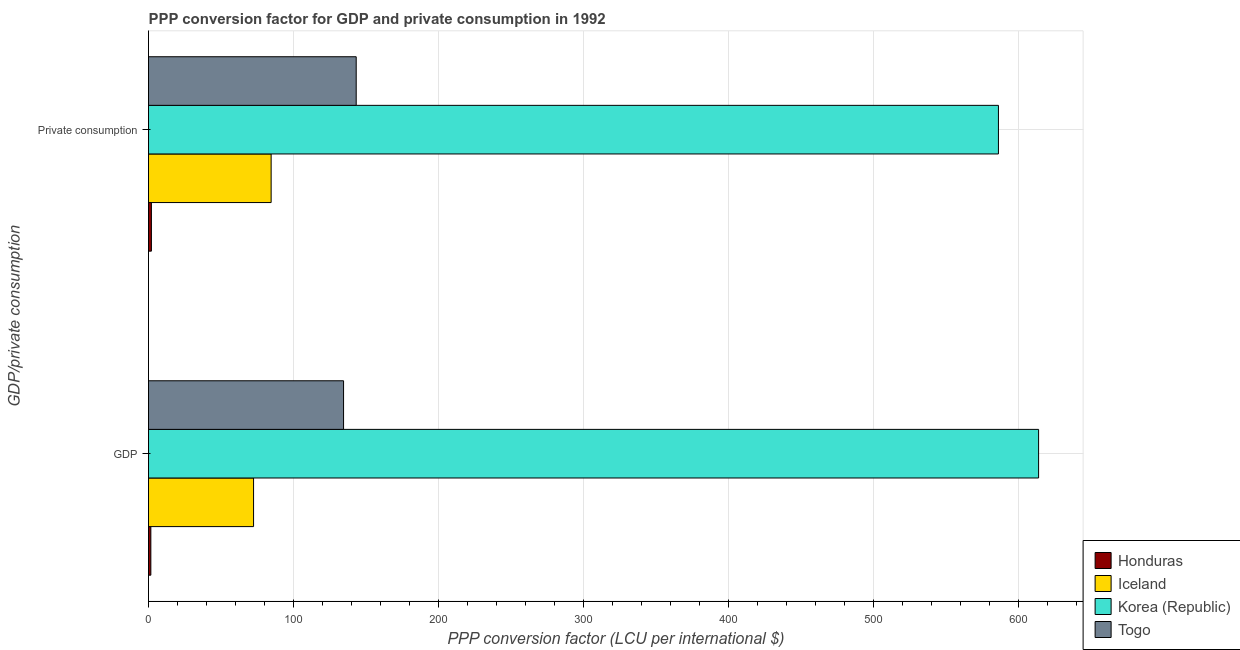How many groups of bars are there?
Your answer should be very brief. 2. Are the number of bars per tick equal to the number of legend labels?
Give a very brief answer. Yes. How many bars are there on the 2nd tick from the top?
Provide a succinct answer. 4. What is the label of the 1st group of bars from the top?
Provide a succinct answer.  Private consumption. What is the ppp conversion factor for gdp in Iceland?
Your answer should be very brief. 72.47. Across all countries, what is the maximum ppp conversion factor for gdp?
Offer a very short reply. 614.12. Across all countries, what is the minimum ppp conversion factor for private consumption?
Offer a very short reply. 1.99. In which country was the ppp conversion factor for gdp minimum?
Your answer should be compact. Honduras. What is the total ppp conversion factor for private consumption in the graph?
Make the answer very short. 816.31. What is the difference between the ppp conversion factor for private consumption in Togo and that in Korea (Republic)?
Offer a terse response. -443.11. What is the difference between the ppp conversion factor for gdp in Togo and the ppp conversion factor for private consumption in Honduras?
Give a very brief answer. 132.58. What is the average ppp conversion factor for private consumption per country?
Offer a very short reply. 204.08. What is the difference between the ppp conversion factor for gdp and ppp conversion factor for private consumption in Togo?
Offer a terse response. -8.73. What is the ratio of the ppp conversion factor for private consumption in Togo to that in Iceland?
Give a very brief answer. 1.69. In how many countries, is the ppp conversion factor for private consumption greater than the average ppp conversion factor for private consumption taken over all countries?
Keep it short and to the point. 1. Are all the bars in the graph horizontal?
Your answer should be compact. Yes. How many countries are there in the graph?
Provide a short and direct response. 4. Are the values on the major ticks of X-axis written in scientific E-notation?
Offer a very short reply. No. Does the graph contain grids?
Ensure brevity in your answer.  Yes. How many legend labels are there?
Offer a very short reply. 4. What is the title of the graph?
Keep it short and to the point. PPP conversion factor for GDP and private consumption in 1992. What is the label or title of the X-axis?
Make the answer very short. PPP conversion factor (LCU per international $). What is the label or title of the Y-axis?
Provide a short and direct response. GDP/private consumption. What is the PPP conversion factor (LCU per international $) in Honduras in GDP?
Give a very brief answer. 1.61. What is the PPP conversion factor (LCU per international $) in Iceland in GDP?
Your answer should be compact. 72.47. What is the PPP conversion factor (LCU per international $) in Korea (Republic) in GDP?
Keep it short and to the point. 614.12. What is the PPP conversion factor (LCU per international $) in Togo in GDP?
Give a very brief answer. 134.57. What is the PPP conversion factor (LCU per international $) in Honduras in  Private consumption?
Make the answer very short. 1.99. What is the PPP conversion factor (LCU per international $) of Iceland in  Private consumption?
Your response must be concise. 84.61. What is the PPP conversion factor (LCU per international $) in Korea (Republic) in  Private consumption?
Provide a short and direct response. 586.41. What is the PPP conversion factor (LCU per international $) of Togo in  Private consumption?
Make the answer very short. 143.3. Across all GDP/private consumption, what is the maximum PPP conversion factor (LCU per international $) in Honduras?
Provide a short and direct response. 1.99. Across all GDP/private consumption, what is the maximum PPP conversion factor (LCU per international $) in Iceland?
Keep it short and to the point. 84.61. Across all GDP/private consumption, what is the maximum PPP conversion factor (LCU per international $) in Korea (Republic)?
Provide a short and direct response. 614.12. Across all GDP/private consumption, what is the maximum PPP conversion factor (LCU per international $) in Togo?
Your answer should be compact. 143.3. Across all GDP/private consumption, what is the minimum PPP conversion factor (LCU per international $) of Honduras?
Your response must be concise. 1.61. Across all GDP/private consumption, what is the minimum PPP conversion factor (LCU per international $) in Iceland?
Offer a very short reply. 72.47. Across all GDP/private consumption, what is the minimum PPP conversion factor (LCU per international $) in Korea (Republic)?
Your response must be concise. 586.41. Across all GDP/private consumption, what is the minimum PPP conversion factor (LCU per international $) in Togo?
Keep it short and to the point. 134.57. What is the total PPP conversion factor (LCU per international $) of Honduras in the graph?
Give a very brief answer. 3.59. What is the total PPP conversion factor (LCU per international $) in Iceland in the graph?
Keep it short and to the point. 157.08. What is the total PPP conversion factor (LCU per international $) in Korea (Republic) in the graph?
Ensure brevity in your answer.  1200.54. What is the total PPP conversion factor (LCU per international $) in Togo in the graph?
Provide a succinct answer. 277.87. What is the difference between the PPP conversion factor (LCU per international $) in Honduras in GDP and that in  Private consumption?
Make the answer very short. -0.38. What is the difference between the PPP conversion factor (LCU per international $) of Iceland in GDP and that in  Private consumption?
Keep it short and to the point. -12.14. What is the difference between the PPP conversion factor (LCU per international $) of Korea (Republic) in GDP and that in  Private consumption?
Provide a succinct answer. 27.71. What is the difference between the PPP conversion factor (LCU per international $) in Togo in GDP and that in  Private consumption?
Your answer should be very brief. -8.73. What is the difference between the PPP conversion factor (LCU per international $) in Honduras in GDP and the PPP conversion factor (LCU per international $) in Iceland in  Private consumption?
Ensure brevity in your answer.  -83. What is the difference between the PPP conversion factor (LCU per international $) in Honduras in GDP and the PPP conversion factor (LCU per international $) in Korea (Republic) in  Private consumption?
Your answer should be very brief. -584.81. What is the difference between the PPP conversion factor (LCU per international $) of Honduras in GDP and the PPP conversion factor (LCU per international $) of Togo in  Private consumption?
Make the answer very short. -141.69. What is the difference between the PPP conversion factor (LCU per international $) in Iceland in GDP and the PPP conversion factor (LCU per international $) in Korea (Republic) in  Private consumption?
Offer a very short reply. -513.94. What is the difference between the PPP conversion factor (LCU per international $) of Iceland in GDP and the PPP conversion factor (LCU per international $) of Togo in  Private consumption?
Your answer should be very brief. -70.83. What is the difference between the PPP conversion factor (LCU per international $) in Korea (Republic) in GDP and the PPP conversion factor (LCU per international $) in Togo in  Private consumption?
Your answer should be compact. 470.83. What is the average PPP conversion factor (LCU per international $) of Honduras per GDP/private consumption?
Your answer should be compact. 1.8. What is the average PPP conversion factor (LCU per international $) of Iceland per GDP/private consumption?
Offer a terse response. 78.54. What is the average PPP conversion factor (LCU per international $) of Korea (Republic) per GDP/private consumption?
Your response must be concise. 600.27. What is the average PPP conversion factor (LCU per international $) of Togo per GDP/private consumption?
Make the answer very short. 138.93. What is the difference between the PPP conversion factor (LCU per international $) in Honduras and PPP conversion factor (LCU per international $) in Iceland in GDP?
Ensure brevity in your answer.  -70.86. What is the difference between the PPP conversion factor (LCU per international $) in Honduras and PPP conversion factor (LCU per international $) in Korea (Republic) in GDP?
Your response must be concise. -612.52. What is the difference between the PPP conversion factor (LCU per international $) in Honduras and PPP conversion factor (LCU per international $) in Togo in GDP?
Your answer should be compact. -132.96. What is the difference between the PPP conversion factor (LCU per international $) of Iceland and PPP conversion factor (LCU per international $) of Korea (Republic) in GDP?
Offer a very short reply. -541.65. What is the difference between the PPP conversion factor (LCU per international $) of Iceland and PPP conversion factor (LCU per international $) of Togo in GDP?
Make the answer very short. -62.1. What is the difference between the PPP conversion factor (LCU per international $) of Korea (Republic) and PPP conversion factor (LCU per international $) of Togo in GDP?
Give a very brief answer. 479.55. What is the difference between the PPP conversion factor (LCU per international $) of Honduras and PPP conversion factor (LCU per international $) of Iceland in  Private consumption?
Ensure brevity in your answer.  -82.62. What is the difference between the PPP conversion factor (LCU per international $) of Honduras and PPP conversion factor (LCU per international $) of Korea (Republic) in  Private consumption?
Your response must be concise. -584.42. What is the difference between the PPP conversion factor (LCU per international $) of Honduras and PPP conversion factor (LCU per international $) of Togo in  Private consumption?
Your response must be concise. -141.31. What is the difference between the PPP conversion factor (LCU per international $) of Iceland and PPP conversion factor (LCU per international $) of Korea (Republic) in  Private consumption?
Your answer should be very brief. -501.8. What is the difference between the PPP conversion factor (LCU per international $) in Iceland and PPP conversion factor (LCU per international $) in Togo in  Private consumption?
Your response must be concise. -58.69. What is the difference between the PPP conversion factor (LCU per international $) of Korea (Republic) and PPP conversion factor (LCU per international $) of Togo in  Private consumption?
Ensure brevity in your answer.  443.11. What is the ratio of the PPP conversion factor (LCU per international $) in Honduras in GDP to that in  Private consumption?
Your answer should be compact. 0.81. What is the ratio of the PPP conversion factor (LCU per international $) in Iceland in GDP to that in  Private consumption?
Your answer should be very brief. 0.86. What is the ratio of the PPP conversion factor (LCU per international $) in Korea (Republic) in GDP to that in  Private consumption?
Your response must be concise. 1.05. What is the ratio of the PPP conversion factor (LCU per international $) of Togo in GDP to that in  Private consumption?
Provide a succinct answer. 0.94. What is the difference between the highest and the second highest PPP conversion factor (LCU per international $) in Honduras?
Make the answer very short. 0.38. What is the difference between the highest and the second highest PPP conversion factor (LCU per international $) in Iceland?
Keep it short and to the point. 12.14. What is the difference between the highest and the second highest PPP conversion factor (LCU per international $) of Korea (Republic)?
Keep it short and to the point. 27.71. What is the difference between the highest and the second highest PPP conversion factor (LCU per international $) of Togo?
Ensure brevity in your answer.  8.73. What is the difference between the highest and the lowest PPP conversion factor (LCU per international $) in Honduras?
Offer a terse response. 0.38. What is the difference between the highest and the lowest PPP conversion factor (LCU per international $) of Iceland?
Offer a very short reply. 12.14. What is the difference between the highest and the lowest PPP conversion factor (LCU per international $) of Korea (Republic)?
Your answer should be compact. 27.71. What is the difference between the highest and the lowest PPP conversion factor (LCU per international $) of Togo?
Ensure brevity in your answer.  8.73. 